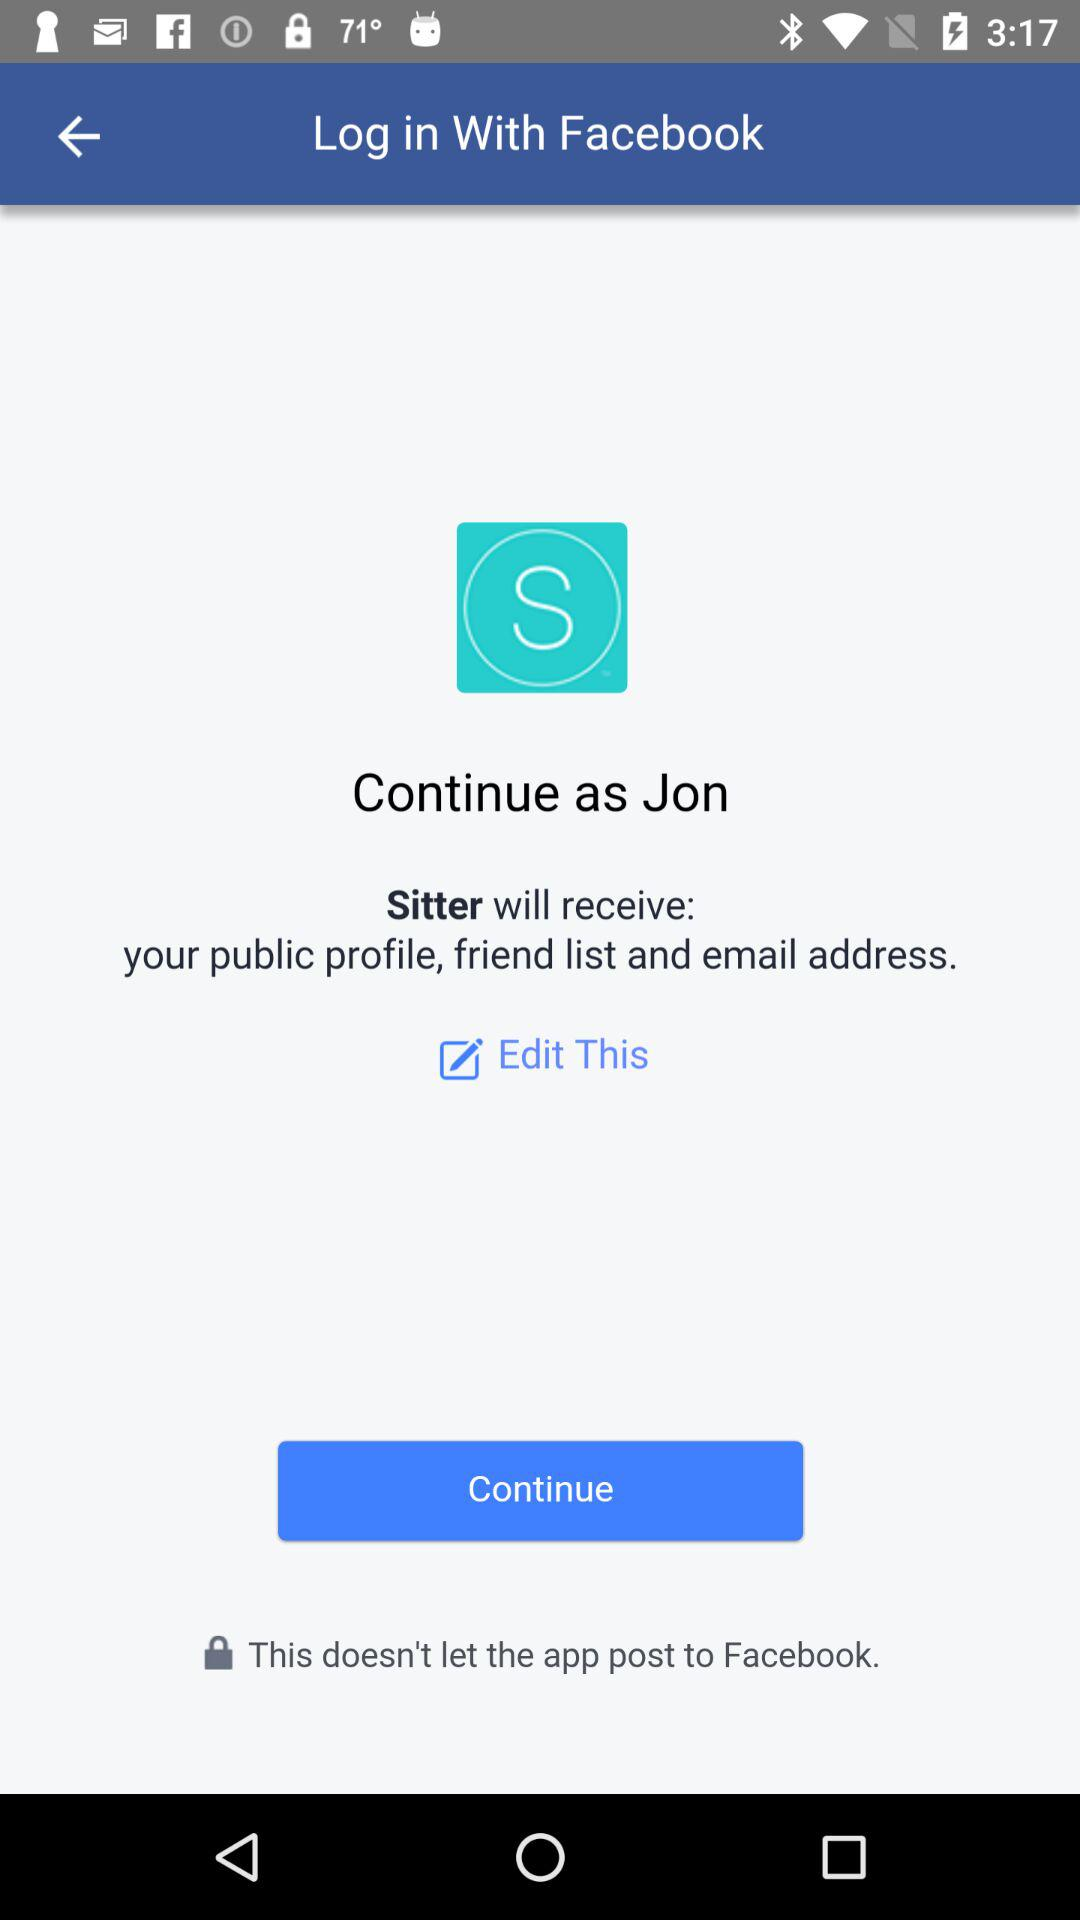What is the user name? The user name is Jon. 